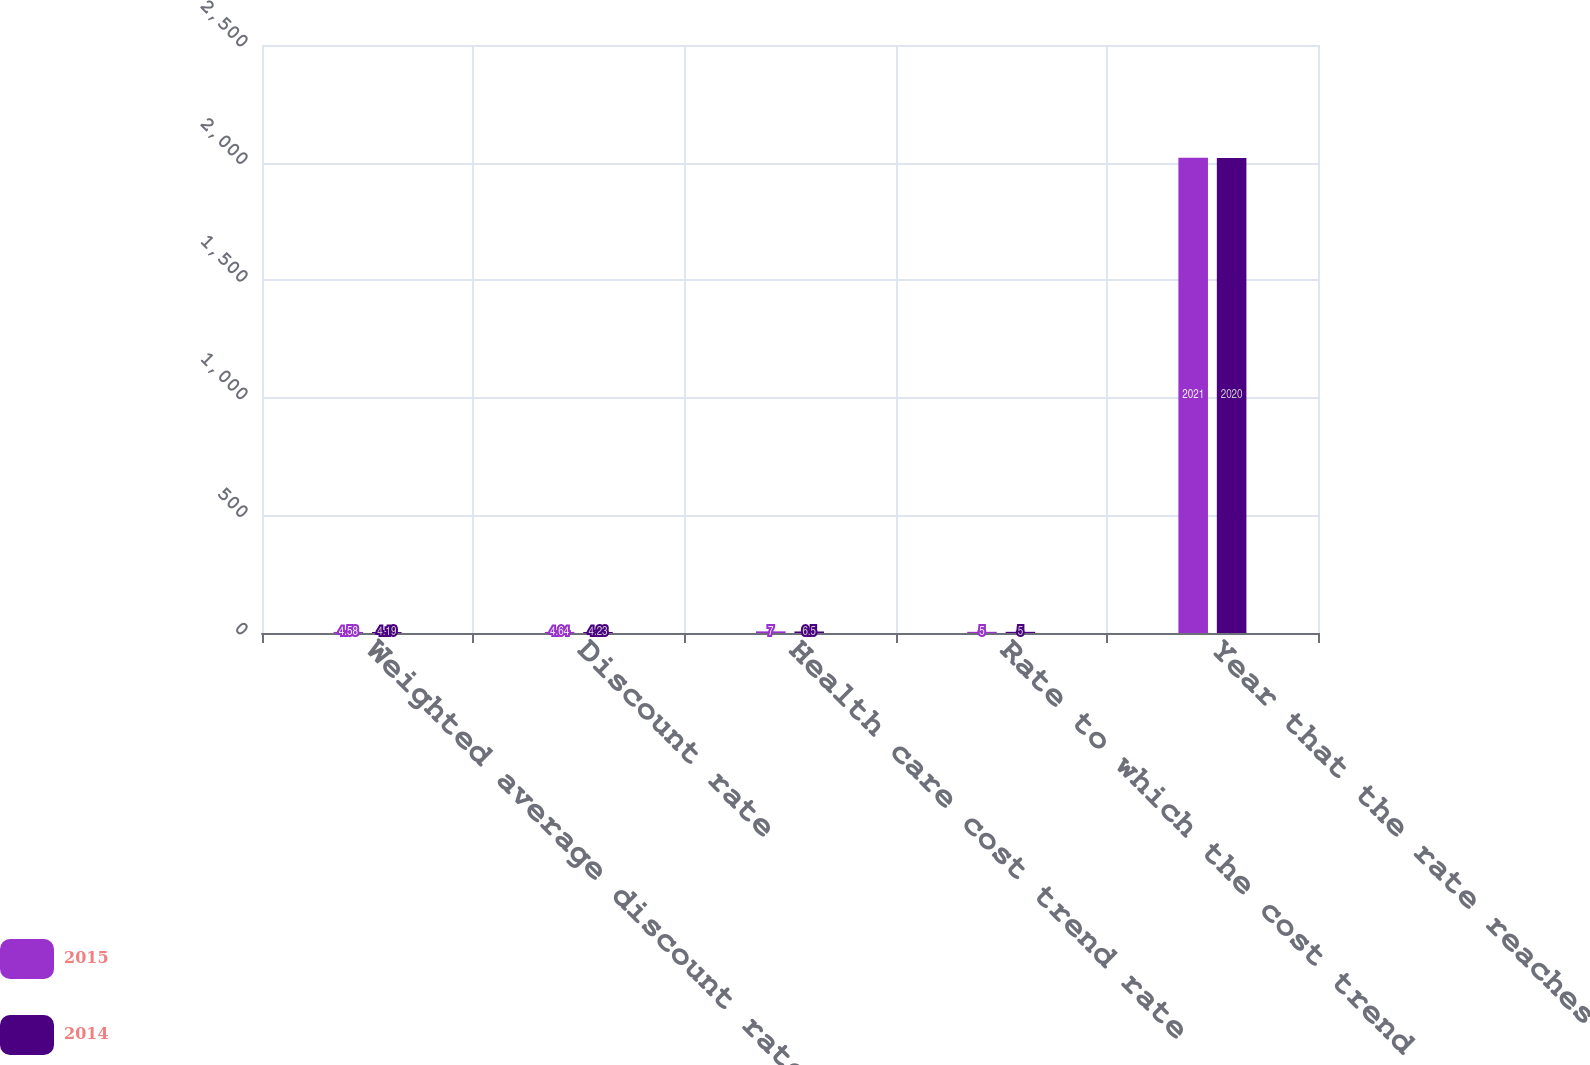<chart> <loc_0><loc_0><loc_500><loc_500><stacked_bar_chart><ecel><fcel>Weighted average discount rate<fcel>Discount rate<fcel>Health care cost trend rate<fcel>Rate to which the cost trend<fcel>Year that the rate reaches the<nl><fcel>2015<fcel>4.58<fcel>4.64<fcel>7<fcel>5<fcel>2021<nl><fcel>2014<fcel>4.19<fcel>4.23<fcel>6.5<fcel>5<fcel>2020<nl></chart> 